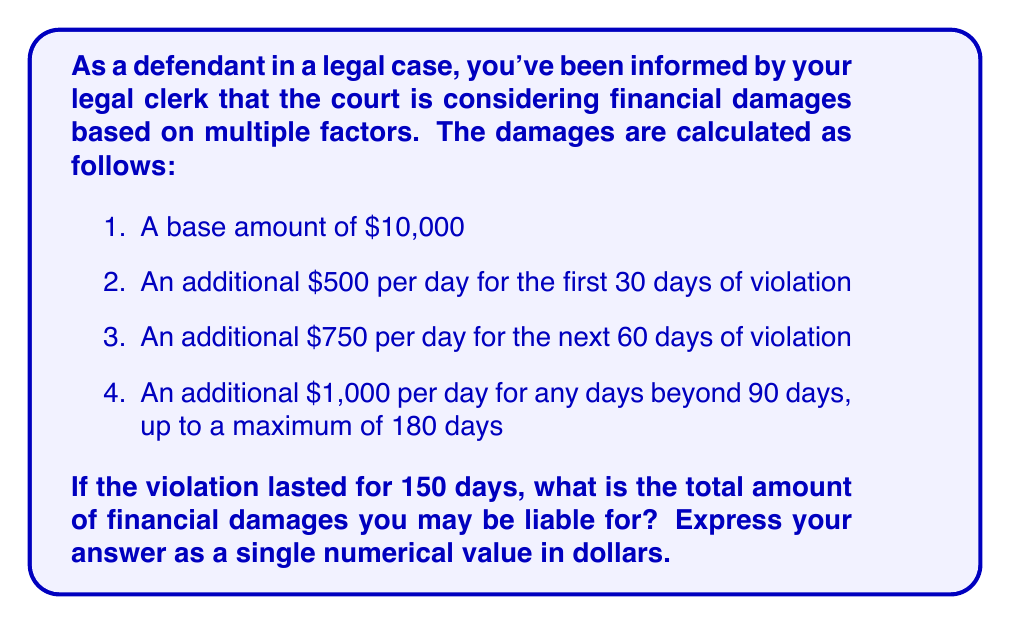Can you solve this math problem? To solve this problem, we need to break it down into parts based on the given time periods and their corresponding daily rates. Let's calculate step by step:

1. Base amount:
   $$10,000$$

2. First 30 days:
   $$30 \times $500 = $15,000$$

3. Next 60 days (days 31-90):
   $$60 \times $750 = $45,000$$

4. Remaining days (days 91-150):
   $$60 \times $1,000 = $60,000$$

Now, we sum up all these components:

$$\text{Total Damages} = $10,000 + $15,000 + $45,000 + $60,000$$

$$\text{Total Damages} = $130,000$$

It's important to note that although the violation lasted 150 days, we didn't exceed the maximum of 180 days mentioned in the question, so we don't need to apply any upper limit to our calculation.
Answer: $130,000 